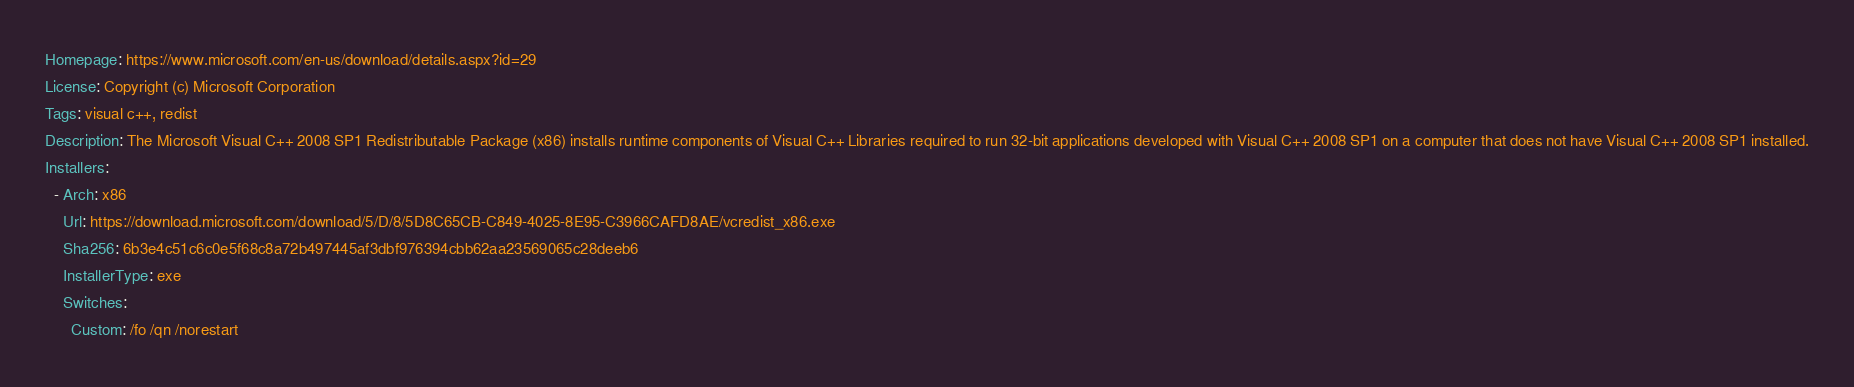<code> <loc_0><loc_0><loc_500><loc_500><_YAML_>Homepage: https://www.microsoft.com/en-us/download/details.aspx?id=29
License: Copyright (c) Microsoft Corporation
Tags: visual c++, redist
Description: The Microsoft Visual C++ 2008 SP1 Redistributable Package (x86) installs runtime components of Visual C++ Libraries required to run 32-bit applications developed with Visual C++ 2008 SP1 on a computer that does not have Visual C++ 2008 SP1 installed.
Installers:
  - Arch: x86
    Url: https://download.microsoft.com/download/5/D/8/5D8C65CB-C849-4025-8E95-C3966CAFD8AE/vcredist_x86.exe
    Sha256: 6b3e4c51c6c0e5f68c8a72b497445af3dbf976394cbb62aa23569065c28deeb6
    InstallerType: exe
    Switches:
      Custom: /fo /qn /norestart
</code> 